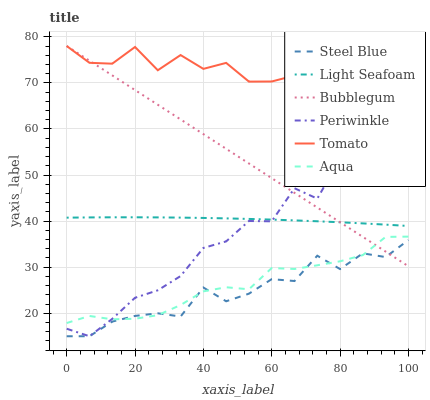Does Steel Blue have the minimum area under the curve?
Answer yes or no. Yes. Does Tomato have the maximum area under the curve?
Answer yes or no. Yes. Does Aqua have the minimum area under the curve?
Answer yes or no. No. Does Aqua have the maximum area under the curve?
Answer yes or no. No. Is Bubblegum the smoothest?
Answer yes or no. Yes. Is Periwinkle the roughest?
Answer yes or no. Yes. Is Aqua the smoothest?
Answer yes or no. No. Is Aqua the roughest?
Answer yes or no. No. Does Steel Blue have the lowest value?
Answer yes or no. Yes. Does Aqua have the lowest value?
Answer yes or no. No. Does Bubblegum have the highest value?
Answer yes or no. Yes. Does Aqua have the highest value?
Answer yes or no. No. Is Aqua less than Light Seafoam?
Answer yes or no. Yes. Is Light Seafoam greater than Steel Blue?
Answer yes or no. Yes. Does Light Seafoam intersect Bubblegum?
Answer yes or no. Yes. Is Light Seafoam less than Bubblegum?
Answer yes or no. No. Is Light Seafoam greater than Bubblegum?
Answer yes or no. No. Does Aqua intersect Light Seafoam?
Answer yes or no. No. 